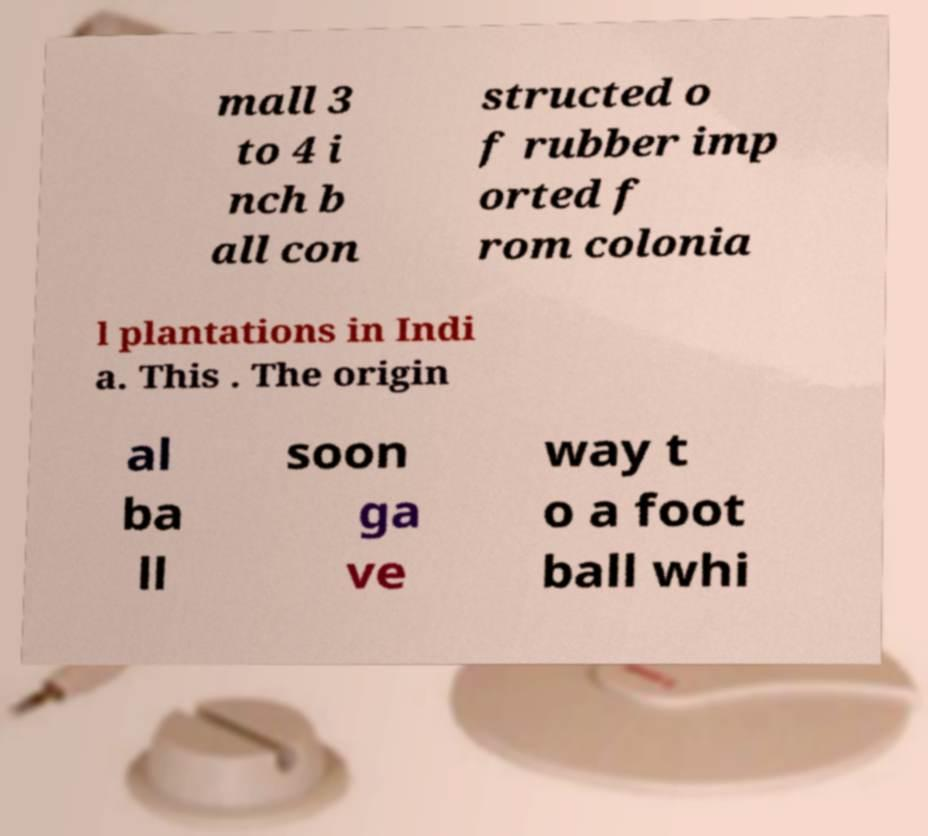There's text embedded in this image that I need extracted. Can you transcribe it verbatim? mall 3 to 4 i nch b all con structed o f rubber imp orted f rom colonia l plantations in Indi a. This . The origin al ba ll soon ga ve way t o a foot ball whi 